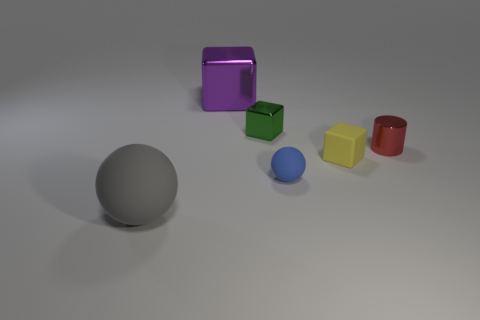There is a big purple metal thing; what number of gray objects are left of it?
Your answer should be very brief. 1. What number of things are big gray balls or large brown shiny cylinders?
Give a very brief answer. 1. What number of green things have the same size as the yellow thing?
Provide a succinct answer. 1. There is a large object right of the ball to the left of the large purple metallic thing; what is its shape?
Keep it short and to the point. Cube. Is the number of red cylinders less than the number of tiny purple rubber objects?
Provide a succinct answer. No. There is a small matte thing behind the blue rubber ball; what is its color?
Keep it short and to the point. Yellow. There is a thing that is both on the left side of the tiny blue thing and in front of the yellow matte block; what material is it?
Your response must be concise. Rubber. The tiny green thing that is made of the same material as the small cylinder is what shape?
Provide a short and direct response. Cube. What number of matte blocks are on the right side of the small object that is right of the small yellow cube?
Your response must be concise. 0. How many objects are both behind the small blue matte sphere and right of the small green shiny object?
Offer a terse response. 2. 